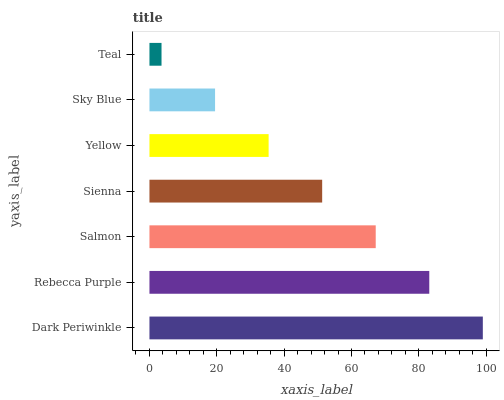Is Teal the minimum?
Answer yes or no. Yes. Is Dark Periwinkle the maximum?
Answer yes or no. Yes. Is Rebecca Purple the minimum?
Answer yes or no. No. Is Rebecca Purple the maximum?
Answer yes or no. No. Is Dark Periwinkle greater than Rebecca Purple?
Answer yes or no. Yes. Is Rebecca Purple less than Dark Periwinkle?
Answer yes or no. Yes. Is Rebecca Purple greater than Dark Periwinkle?
Answer yes or no. No. Is Dark Periwinkle less than Rebecca Purple?
Answer yes or no. No. Is Sienna the high median?
Answer yes or no. Yes. Is Sienna the low median?
Answer yes or no. Yes. Is Dark Periwinkle the high median?
Answer yes or no. No. Is Yellow the low median?
Answer yes or no. No. 